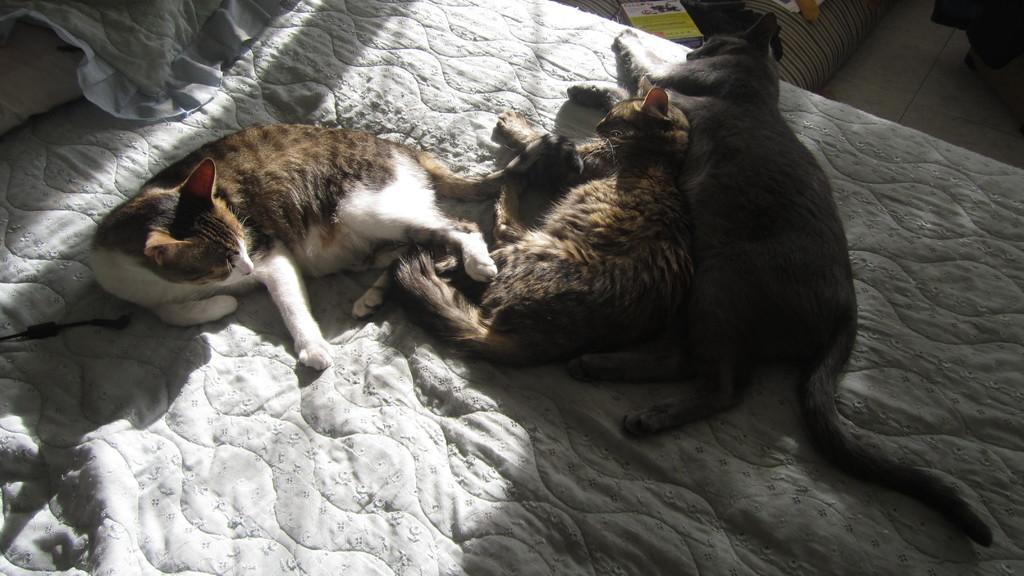Could you give a brief overview of what you see in this image? In this image, we can see three cats sleeping on the bed. 